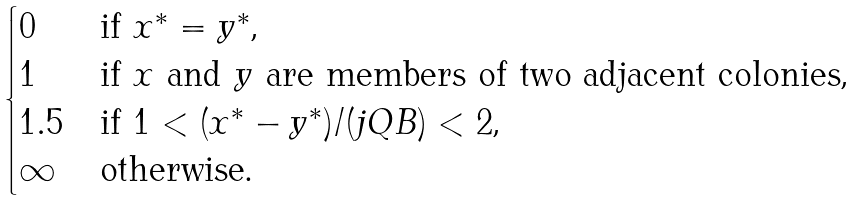<formula> <loc_0><loc_0><loc_500><loc_500>\begin{cases} 0 & \text {if $x^{*}=y^{*}$,} \\ 1 & \text {if $x$ and $y$ are members of two adjacent colonies,} \\ 1 . 5 & \text {if $1 < (x^{*}-y^{*})/(jQB) < 2$,} \\ \infty & \text {otherwise.} \end{cases}</formula> 